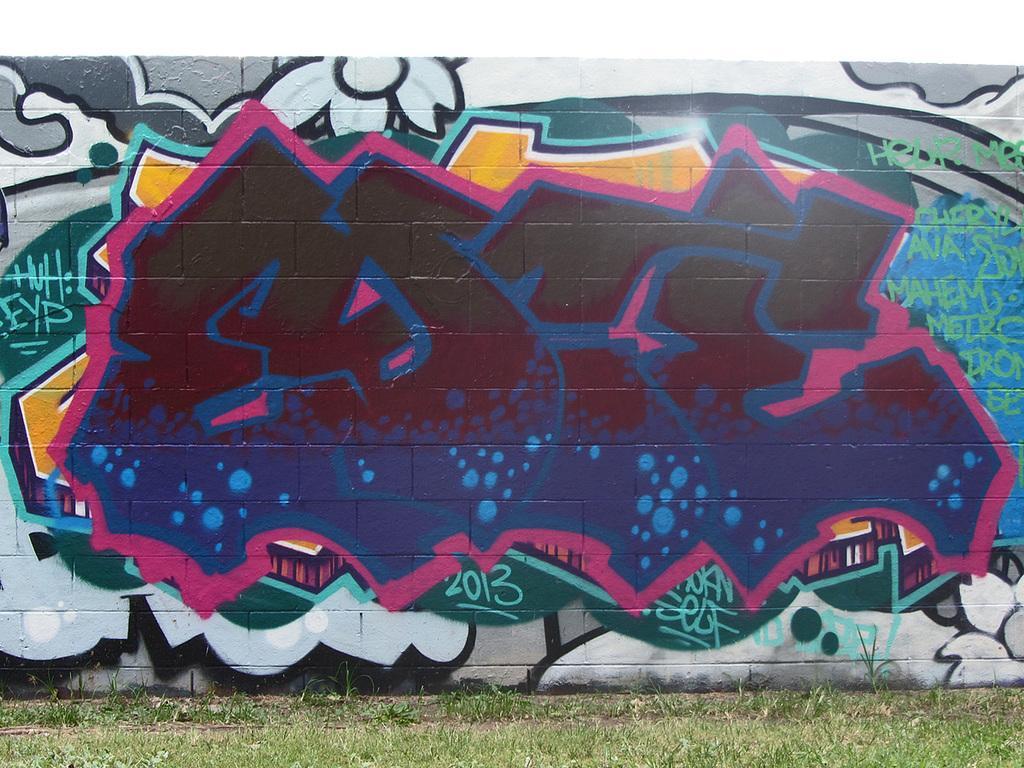Could you give a brief overview of what you see in this image? In this picture we can see painted wall, grass on the land. 